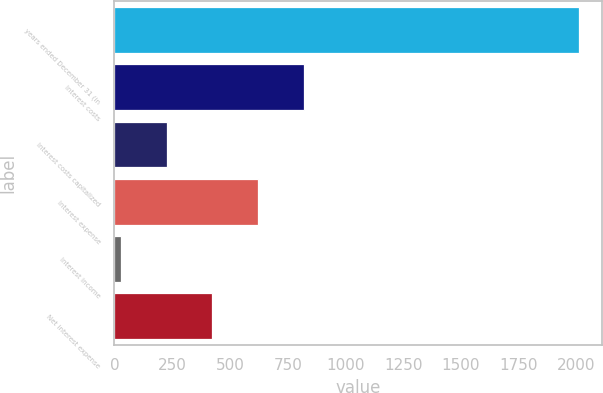Convert chart to OTSL. <chart><loc_0><loc_0><loc_500><loc_500><bar_chart><fcel>years ended December 31 (in<fcel>Interest costs<fcel>Interest costs capitalized<fcel>Interest expense<fcel>Interest income<fcel>Net interest expense<nl><fcel>2010<fcel>820.8<fcel>226.2<fcel>622.6<fcel>28<fcel>424.4<nl></chart> 